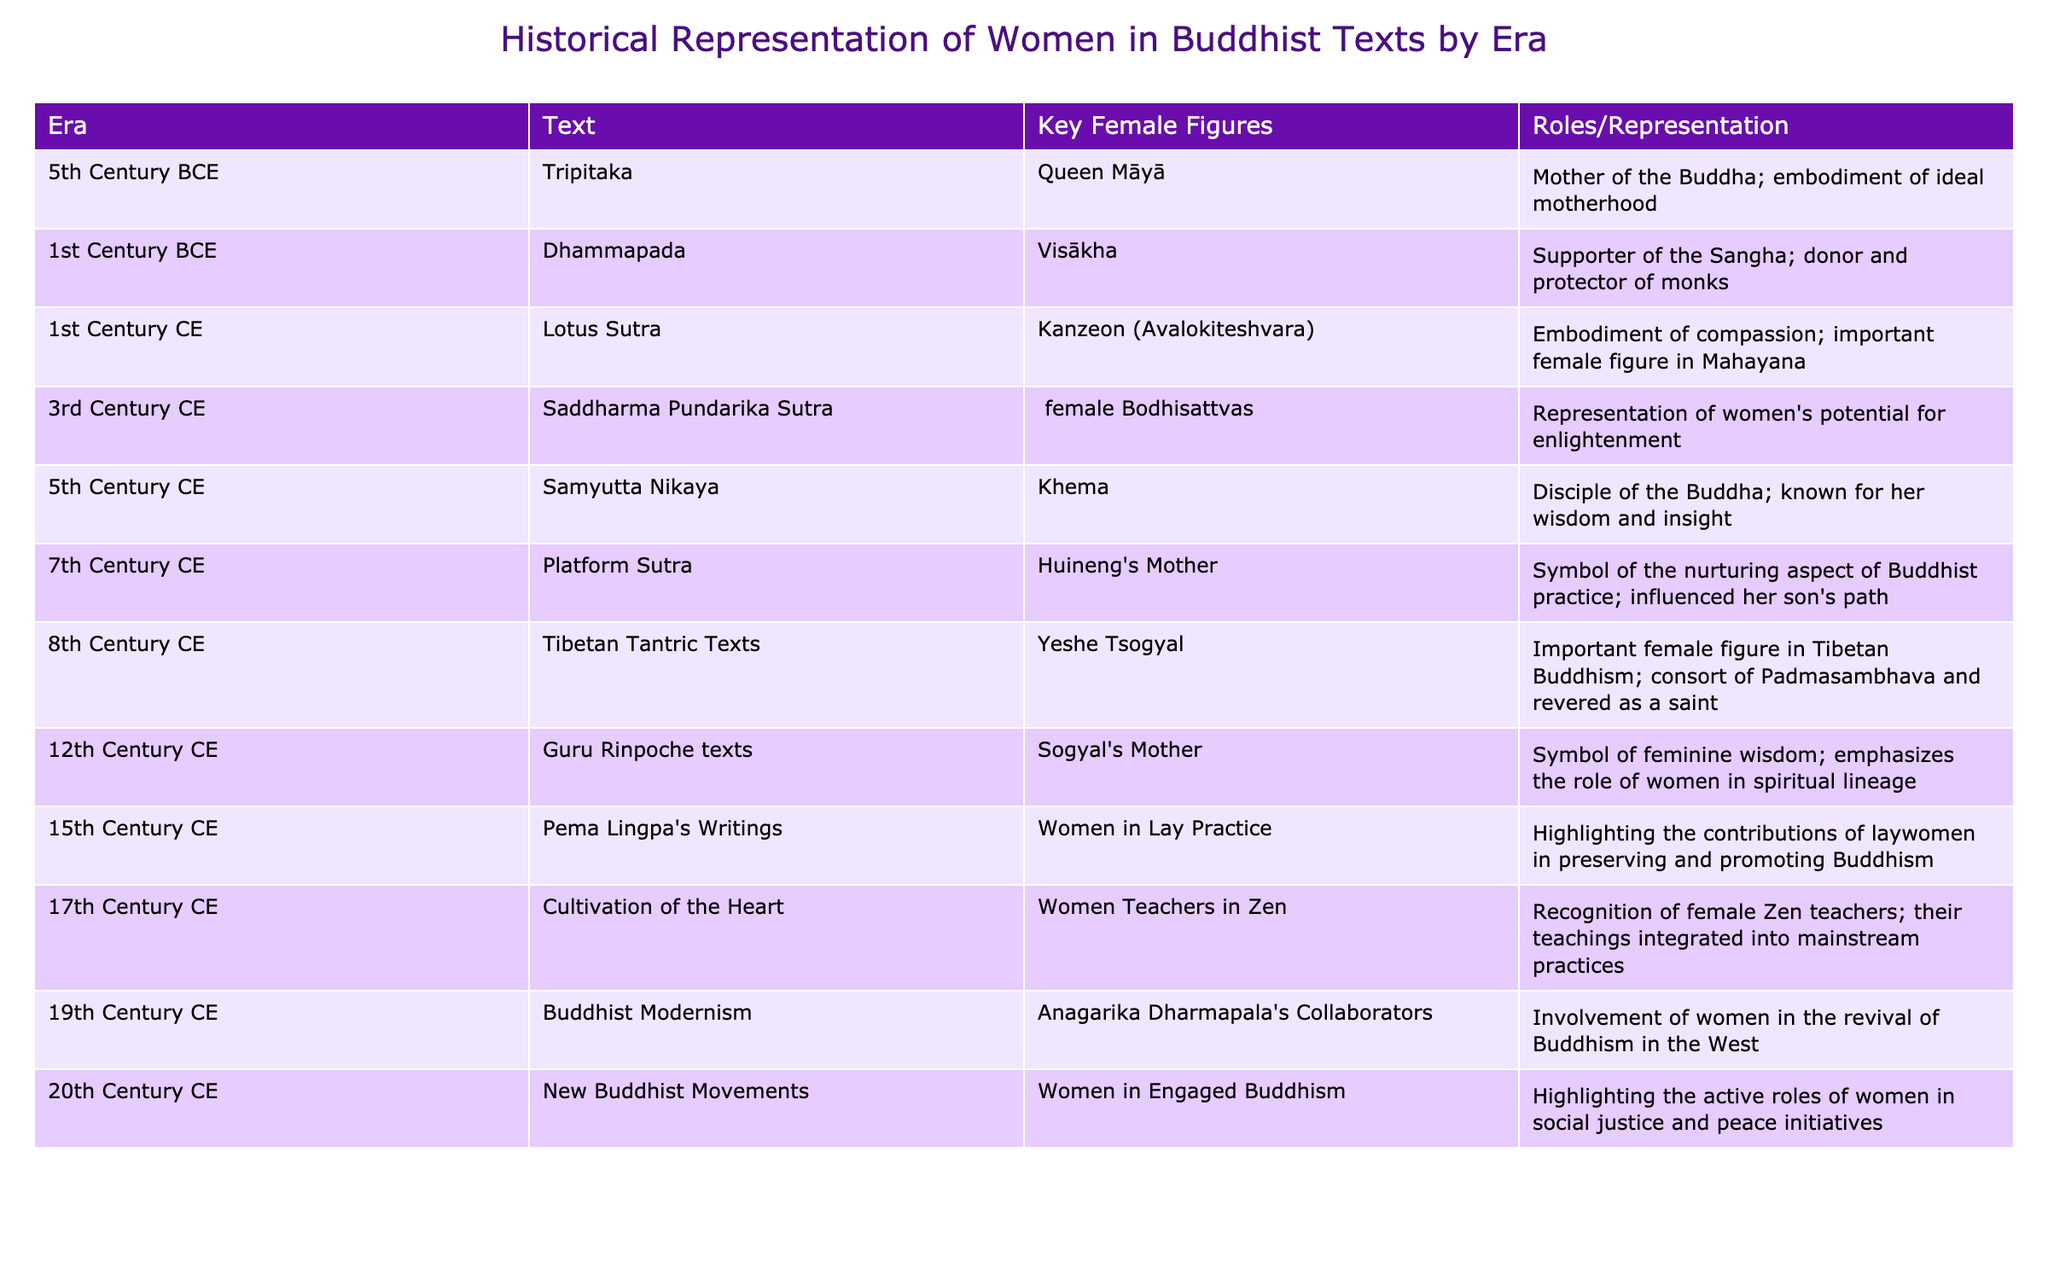What are the key female figures mentioned in the 3rd Century CE? The table lists "female Bodhisattvas" as the key female figures in the 3rd Century CE under the "Saddharma Pundarika Sutra" entry.
Answer: female Bodhisattvas Which era features Kanzeon (Avalokiteshvara)? The table indicates that Kanzeon (Avalokiteshvara) is featured in the 1st Century CE in the "Lotus Sutra".
Answer: 1st Century CE How many centuries are represented in the data from the 5th Century BCE to the 20th Century CE? The data spans from the 5th Century BCE to the 20th Century CE, which is a total of 25 centuries (20th - (-5) = 25).
Answer: 25 In which text is the importance of laywomen highlighted? According to the table, the importance of laywomen is highlighted in Pema Lingpa's Writings from the 15th Century CE.
Answer: Pema Lingpa's Writings Is Khema known for her wisdom? Yes, the table states that Khema is known for her wisdom and insight in the 5th Century CE, specifically in the "Samyutta Nikaya" entry.
Answer: Yes Which century has the representation of women in engaged Buddhism? The table indicates that the 20th Century CE illustrates the representation of women in engaged Buddhism.
Answer: 20th Century CE What is the role of Huineng's Mother as per the table? The role of Huineng's Mother is described as a symbol of the nurturing aspect of Buddhist practice and her influence on her son's path in the 7th Century CE.
Answer: Symbol of nurturing aspect List the key female figure associated with the Tibetan Tantric Texts. The key female figure associated with the Tibetan Tantric Texts is Yeshe Tsogyal, noted as an important female figure in Tibetan Buddhism.
Answer: Yeshe Tsogyal How do the representations of women evolve from the 5th Century BCE to the 20th Century CE? Analyzing the table shows that representations of women evolve from ideal motherhood in the 5th Century BCE to active roles in social justice and peace initiatives in the 20th Century CE, reflecting a shift in societal roles.
Answer: Evolved from motherhood to active roles in society 